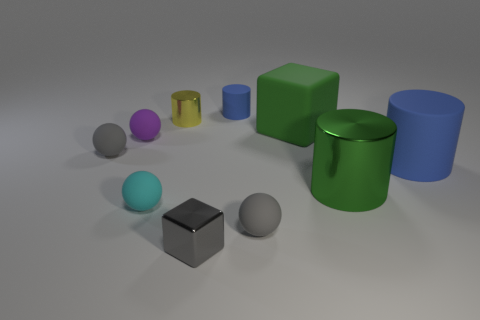Subtract all brown cylinders. Subtract all purple spheres. How many cylinders are left? 4 Subtract all cubes. How many objects are left? 8 Add 3 gray metallic things. How many gray metallic things are left? 4 Add 5 small green metal objects. How many small green metal objects exist? 5 Subtract 1 green cylinders. How many objects are left? 9 Subtract all cubes. Subtract all large gray metallic things. How many objects are left? 8 